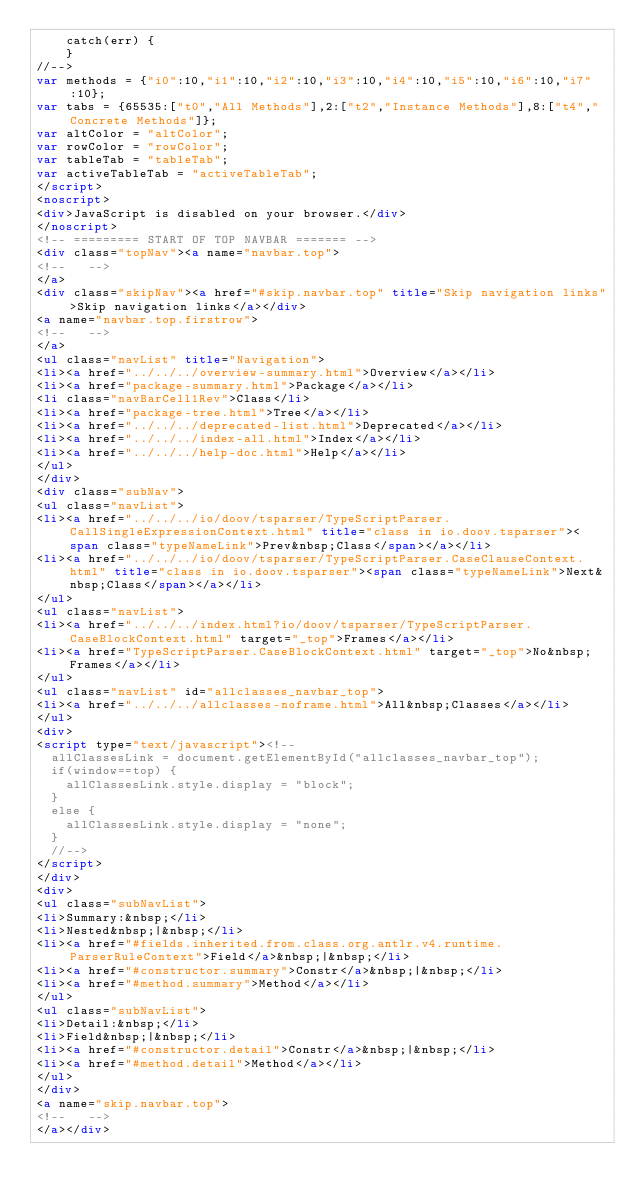<code> <loc_0><loc_0><loc_500><loc_500><_HTML_>    catch(err) {
    }
//-->
var methods = {"i0":10,"i1":10,"i2":10,"i3":10,"i4":10,"i5":10,"i6":10,"i7":10};
var tabs = {65535:["t0","All Methods"],2:["t2","Instance Methods"],8:["t4","Concrete Methods"]};
var altColor = "altColor";
var rowColor = "rowColor";
var tableTab = "tableTab";
var activeTableTab = "activeTableTab";
</script>
<noscript>
<div>JavaScript is disabled on your browser.</div>
</noscript>
<!-- ========= START OF TOP NAVBAR ======= -->
<div class="topNav"><a name="navbar.top">
<!--   -->
</a>
<div class="skipNav"><a href="#skip.navbar.top" title="Skip navigation links">Skip navigation links</a></div>
<a name="navbar.top.firstrow">
<!--   -->
</a>
<ul class="navList" title="Navigation">
<li><a href="../../../overview-summary.html">Overview</a></li>
<li><a href="package-summary.html">Package</a></li>
<li class="navBarCell1Rev">Class</li>
<li><a href="package-tree.html">Tree</a></li>
<li><a href="../../../deprecated-list.html">Deprecated</a></li>
<li><a href="../../../index-all.html">Index</a></li>
<li><a href="../../../help-doc.html">Help</a></li>
</ul>
</div>
<div class="subNav">
<ul class="navList">
<li><a href="../../../io/doov/tsparser/TypeScriptParser.CallSingleExpressionContext.html" title="class in io.doov.tsparser"><span class="typeNameLink">Prev&nbsp;Class</span></a></li>
<li><a href="../../../io/doov/tsparser/TypeScriptParser.CaseClauseContext.html" title="class in io.doov.tsparser"><span class="typeNameLink">Next&nbsp;Class</span></a></li>
</ul>
<ul class="navList">
<li><a href="../../../index.html?io/doov/tsparser/TypeScriptParser.CaseBlockContext.html" target="_top">Frames</a></li>
<li><a href="TypeScriptParser.CaseBlockContext.html" target="_top">No&nbsp;Frames</a></li>
</ul>
<ul class="navList" id="allclasses_navbar_top">
<li><a href="../../../allclasses-noframe.html">All&nbsp;Classes</a></li>
</ul>
<div>
<script type="text/javascript"><!--
  allClassesLink = document.getElementById("allclasses_navbar_top");
  if(window==top) {
    allClassesLink.style.display = "block";
  }
  else {
    allClassesLink.style.display = "none";
  }
  //-->
</script>
</div>
<div>
<ul class="subNavList">
<li>Summary:&nbsp;</li>
<li>Nested&nbsp;|&nbsp;</li>
<li><a href="#fields.inherited.from.class.org.antlr.v4.runtime.ParserRuleContext">Field</a>&nbsp;|&nbsp;</li>
<li><a href="#constructor.summary">Constr</a>&nbsp;|&nbsp;</li>
<li><a href="#method.summary">Method</a></li>
</ul>
<ul class="subNavList">
<li>Detail:&nbsp;</li>
<li>Field&nbsp;|&nbsp;</li>
<li><a href="#constructor.detail">Constr</a>&nbsp;|&nbsp;</li>
<li><a href="#method.detail">Method</a></li>
</ul>
</div>
<a name="skip.navbar.top">
<!--   -->
</a></div></code> 